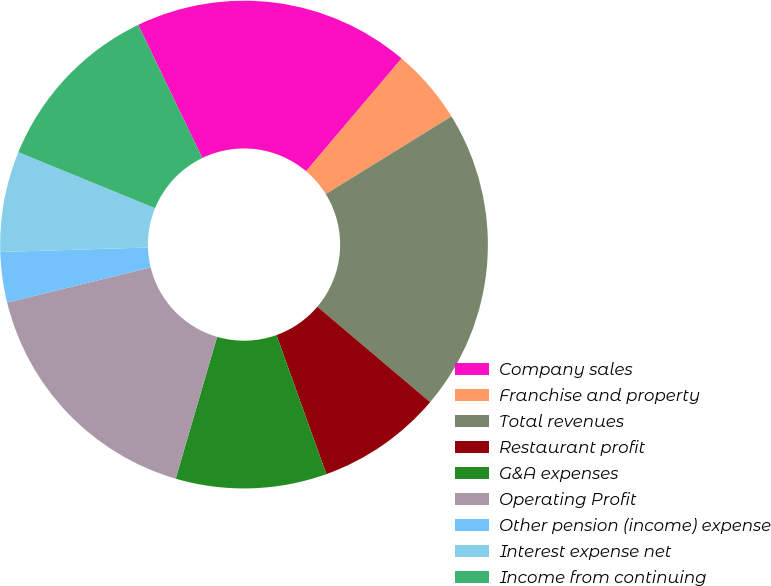Convert chart. <chart><loc_0><loc_0><loc_500><loc_500><pie_chart><fcel>Company sales<fcel>Franchise and property<fcel>Total revenues<fcel>Restaurant profit<fcel>G&A expenses<fcel>Operating Profit<fcel>Other pension (income) expense<fcel>Interest expense net<fcel>Income from continuing<nl><fcel>18.33%<fcel>5.01%<fcel>19.99%<fcel>8.34%<fcel>10.0%<fcel>16.66%<fcel>3.34%<fcel>6.67%<fcel>11.67%<nl></chart> 